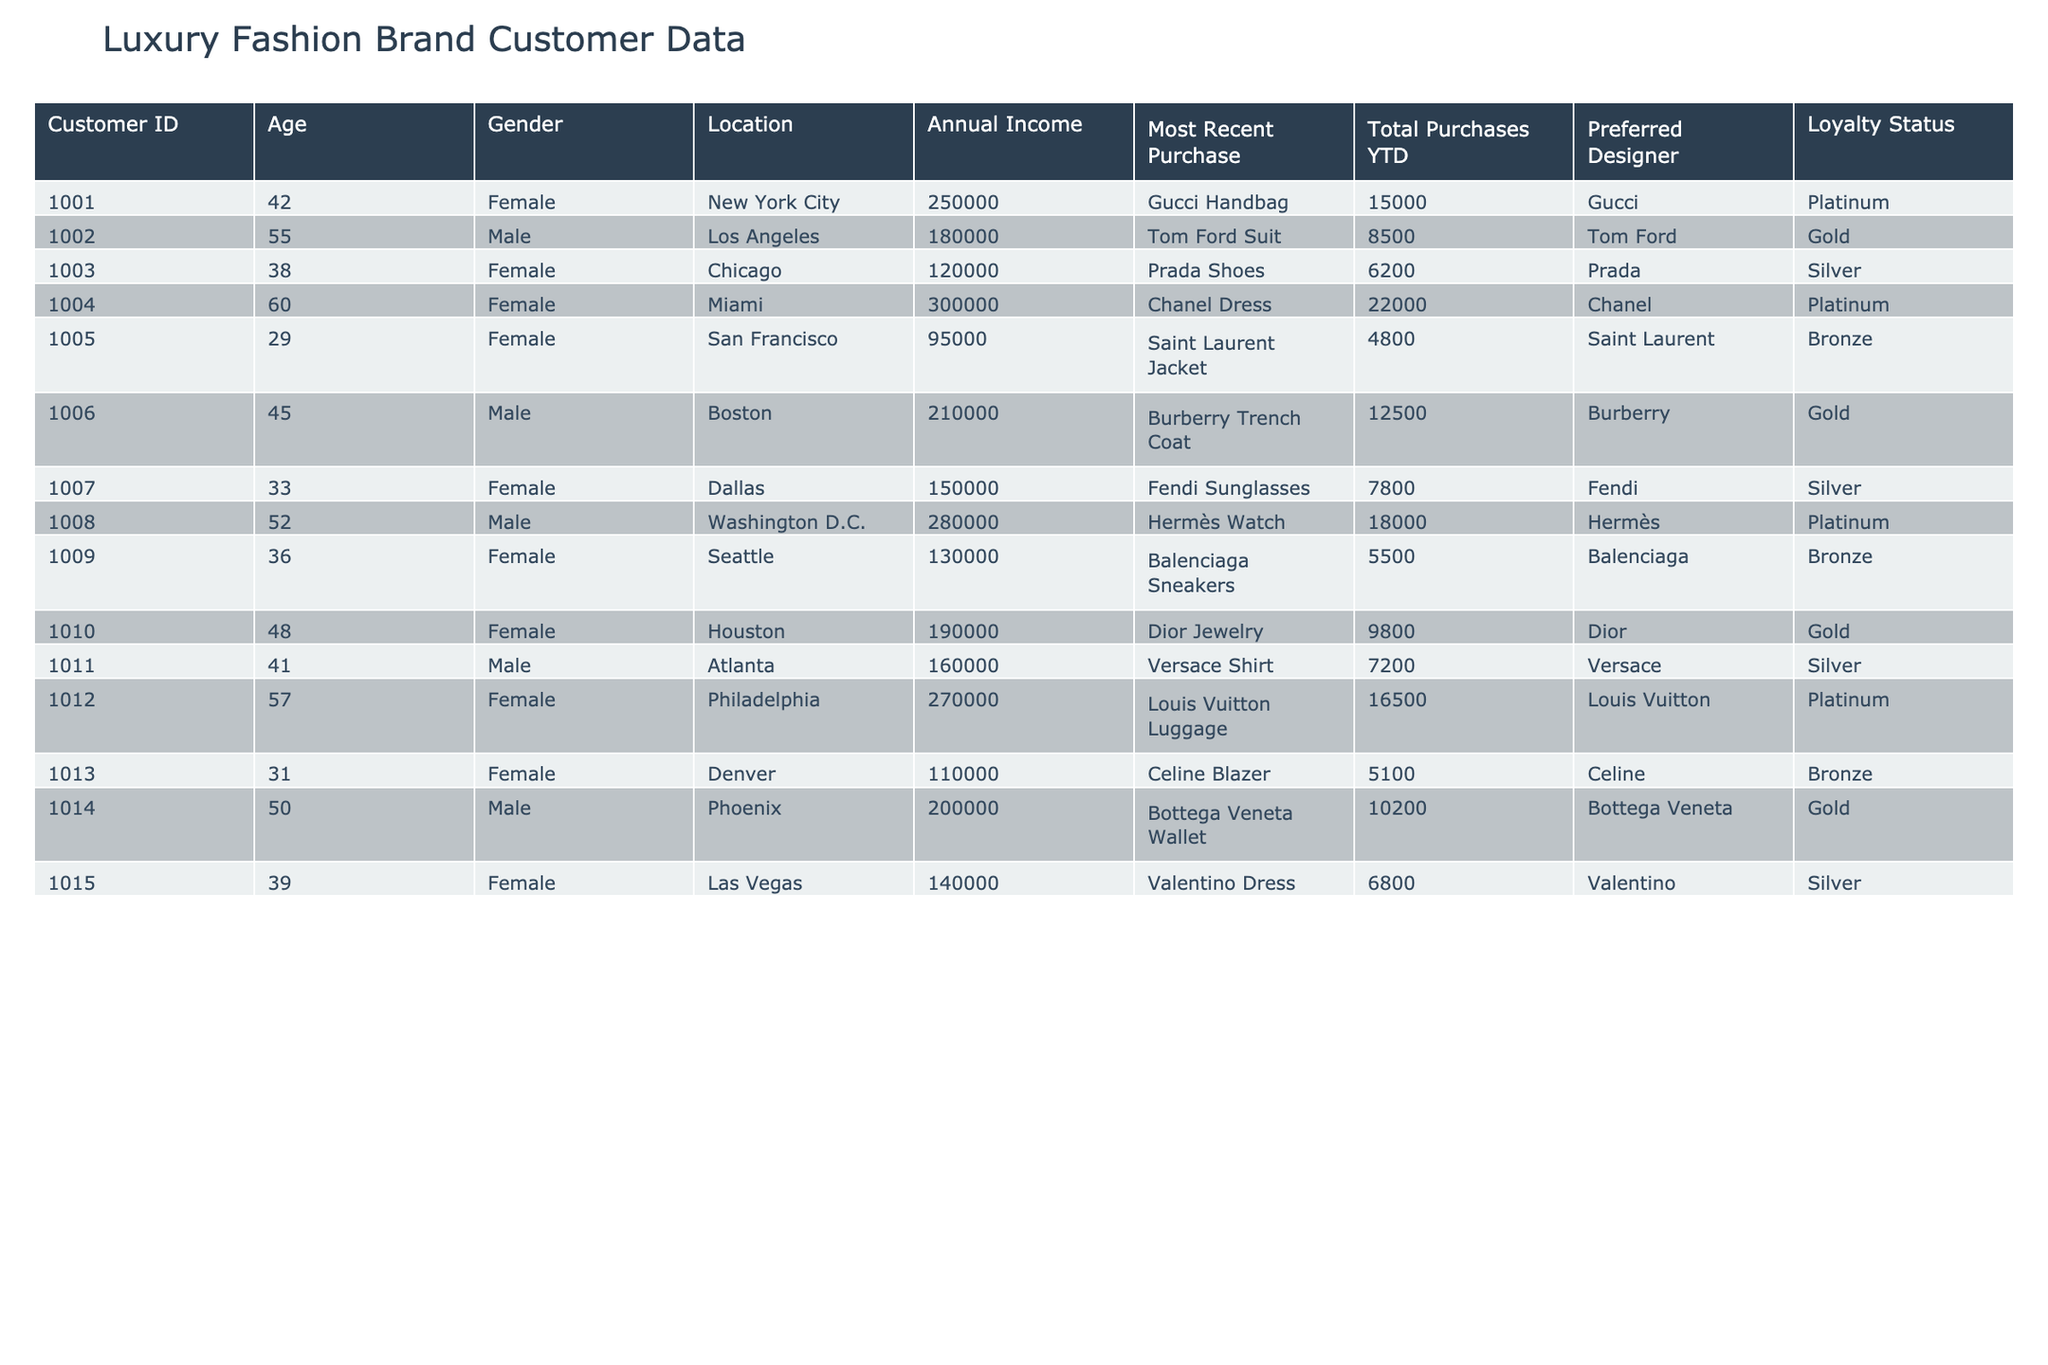What is the age of the youngest customer? The youngest customer listed is Customer ID 1005, who is 29 years old.
Answer: 29 Which designer has the highest loyalty status among the customers? The loyalty status of all customers shows that several have a "Platinum" status, including Gucci, Chanel, and Hermès.
Answer: Gucci, Chanel, and Hermès What is the total annual income of customers based in New York City? The customer from New York City (Customer ID 1001) has an annual income of 250,000. There is only one customer from that location.
Answer: 250000 How many customers have a total purchase value greater than 10,000? The customers with total purchases greater than 10,000 are Customer ID 1001, 1006, 1004, 1008, and 1012, totaling 5 customers.
Answer: 5 What is the average age of customers with "Gold" loyalty status? There are three customers with "Gold" status (Customer IDs 1002, 1006, and 1010), with ages 55, 45, and 48 respectively. The average age is (55 + 45 + 48) / 3 = 49.33.
Answer: 49.33 Which city has the customer with the highest annual income? Customer ID 1004 from Miami has the highest annual income of 300,000, which is the maximum among all customers.
Answer: Miami Is there any male customer who prefers Valentino as their designer? A review of the table indicates there are no male customers listed with Valentino as their preferred designer; the only Valentino customer is female.
Answer: No What is the total annual income of customers who have made purchases of more than 7,000? The customers with purchases over 7,000 are Customers 1001, 1002, 1004, 1006, 1008, and 1012, with incomes of 250,000, 180,000, 300,000, 210,000, 280,000, and 270,000 respectively. Adding these yields a total income of 250,000 + 180,000 + 300,000 + 210,000 + 280,000 + 270,000 = 1,490,000.
Answer: 1490000 Which customer made the most recent purchase of a Dior item? Customer ID 1010 made the most recent purchase of Dior Jewelry, listed in the table.
Answer: 1010 What is the median total purchase value among all customers? The total purchase values are 15000, 8500, 6200, 22000, 4800, 12500, 7800, 18000, 5500, 9800, 7200, 16500, 5100, 10200, and 6800. Arranging them in order gives: 4800, 5100, 5500, 6200, 6800, 7200, 7800, 8500, 9800, 10200, 12500, 15000, 16500, 18000, 22000. The median is the middle value, which is (7800 + 8500) / 2 = 8150.
Answer: 8150 